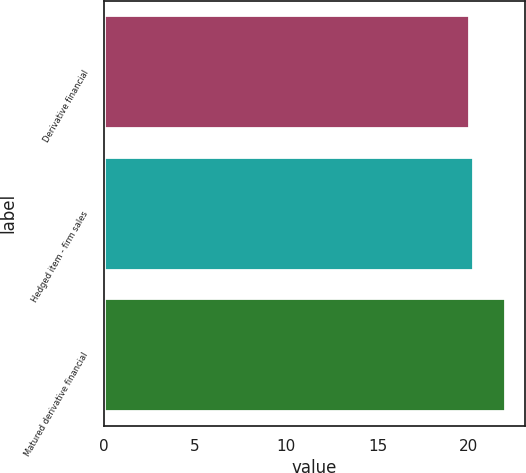Convert chart. <chart><loc_0><loc_0><loc_500><loc_500><bar_chart><fcel>Derivative financial<fcel>Hedged item - firm sales<fcel>Matured derivative financial<nl><fcel>20<fcel>20.2<fcel>22<nl></chart> 